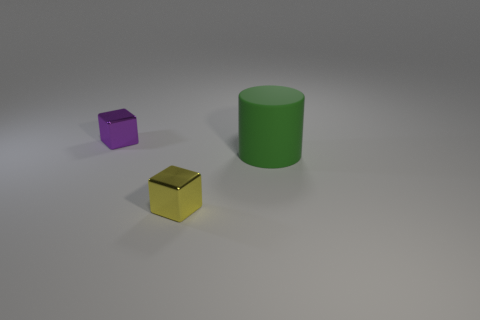Subtract 1 blocks. How many blocks are left? 1 Add 2 green cylinders. How many objects exist? 5 Subtract all yellow blocks. How many blocks are left? 1 Subtract 0 yellow spheres. How many objects are left? 3 Subtract all blocks. How many objects are left? 1 Subtract all gray blocks. Subtract all green spheres. How many blocks are left? 2 Subtract all yellow cylinders. How many purple blocks are left? 1 Subtract all tiny blocks. Subtract all green rubber objects. How many objects are left? 0 Add 2 cubes. How many cubes are left? 4 Add 3 tiny red things. How many tiny red things exist? 3 